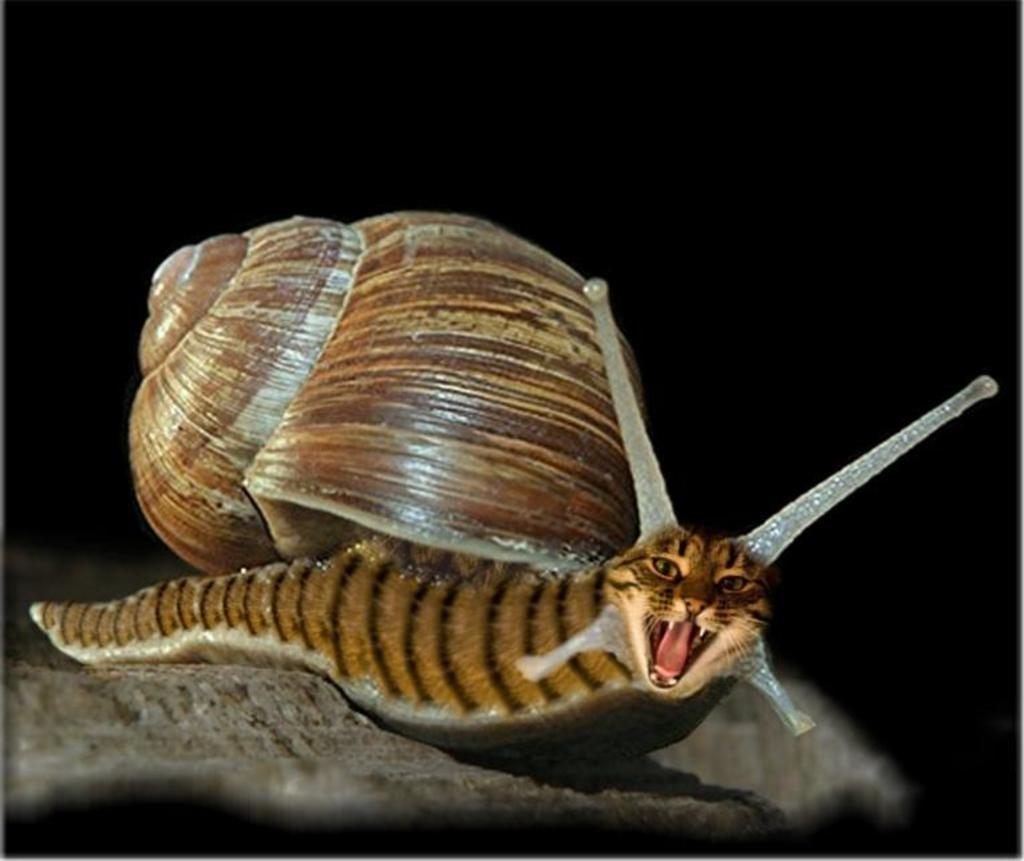Could you give a brief overview of what you see in this image? In this image there is a snail on the rock. Background is in black color. 